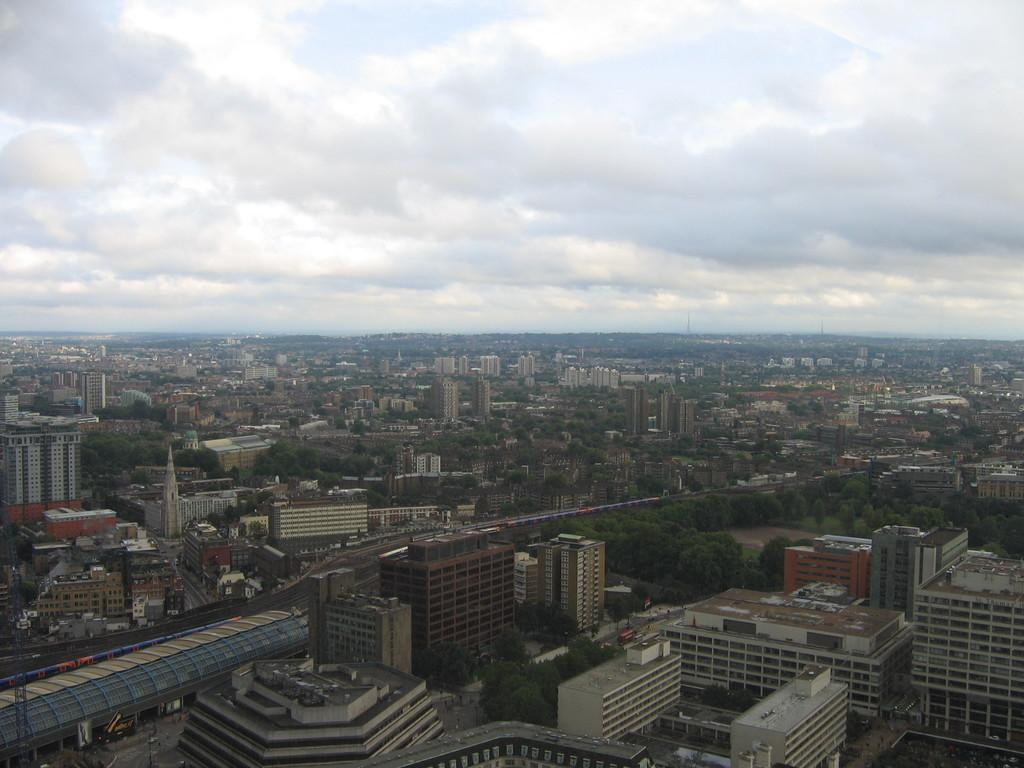What perspective is used to capture the image? The image is taken from a top view. What types of structures are visible in the image? There are many buildings and towers in the image. What other natural elements can be seen in the image? There are trees in the image. How would you describe the weather based on the image? The sky is cloudy in the image, suggesting a potentially overcast or cloudy day. What type of cheese is being used to create the rhythm in the image? There is no cheese or rhythm present in the image; it features buildings, towers, trees, and a cloudy sky. 